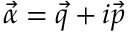Convert formula to latex. <formula><loc_0><loc_0><loc_500><loc_500>\vec { \alpha } = \vec { q } + i \vec { p }</formula> 